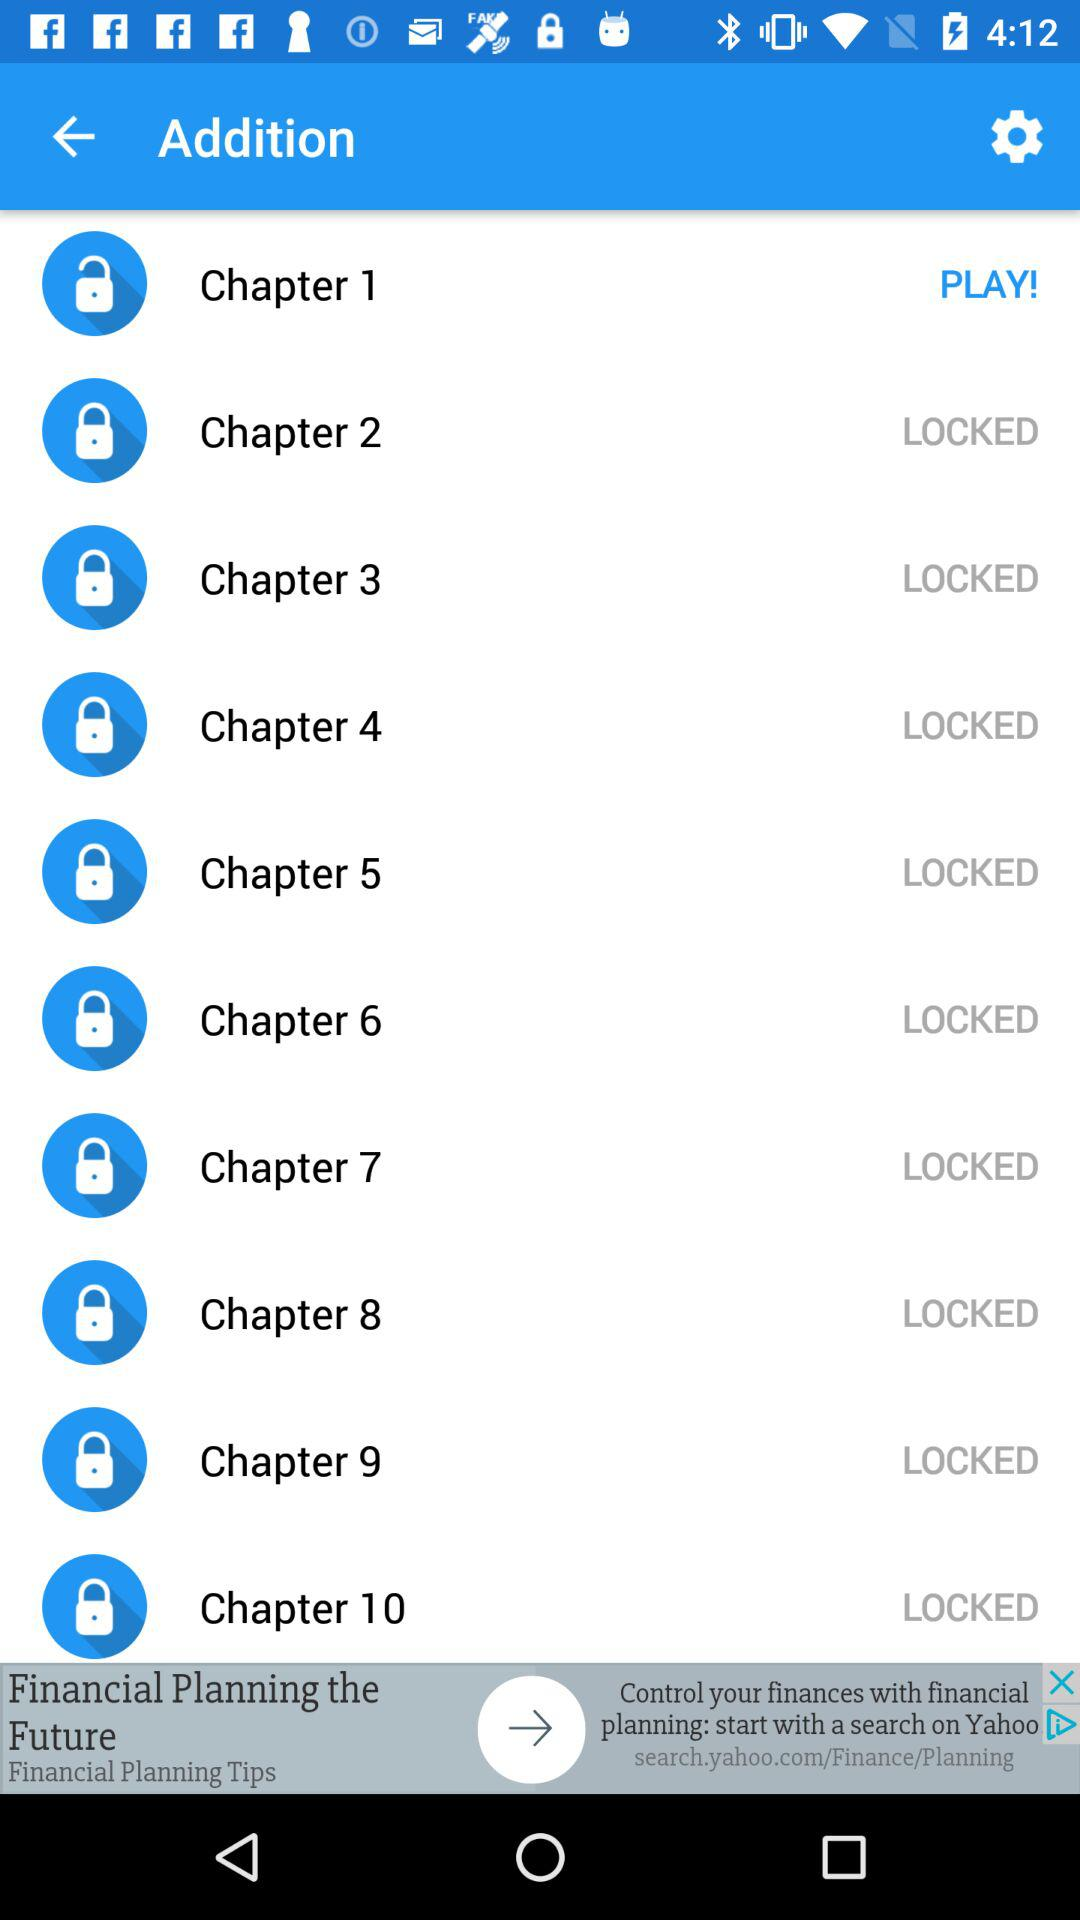How many chapters are locked?
Answer the question using a single word or phrase. 9 